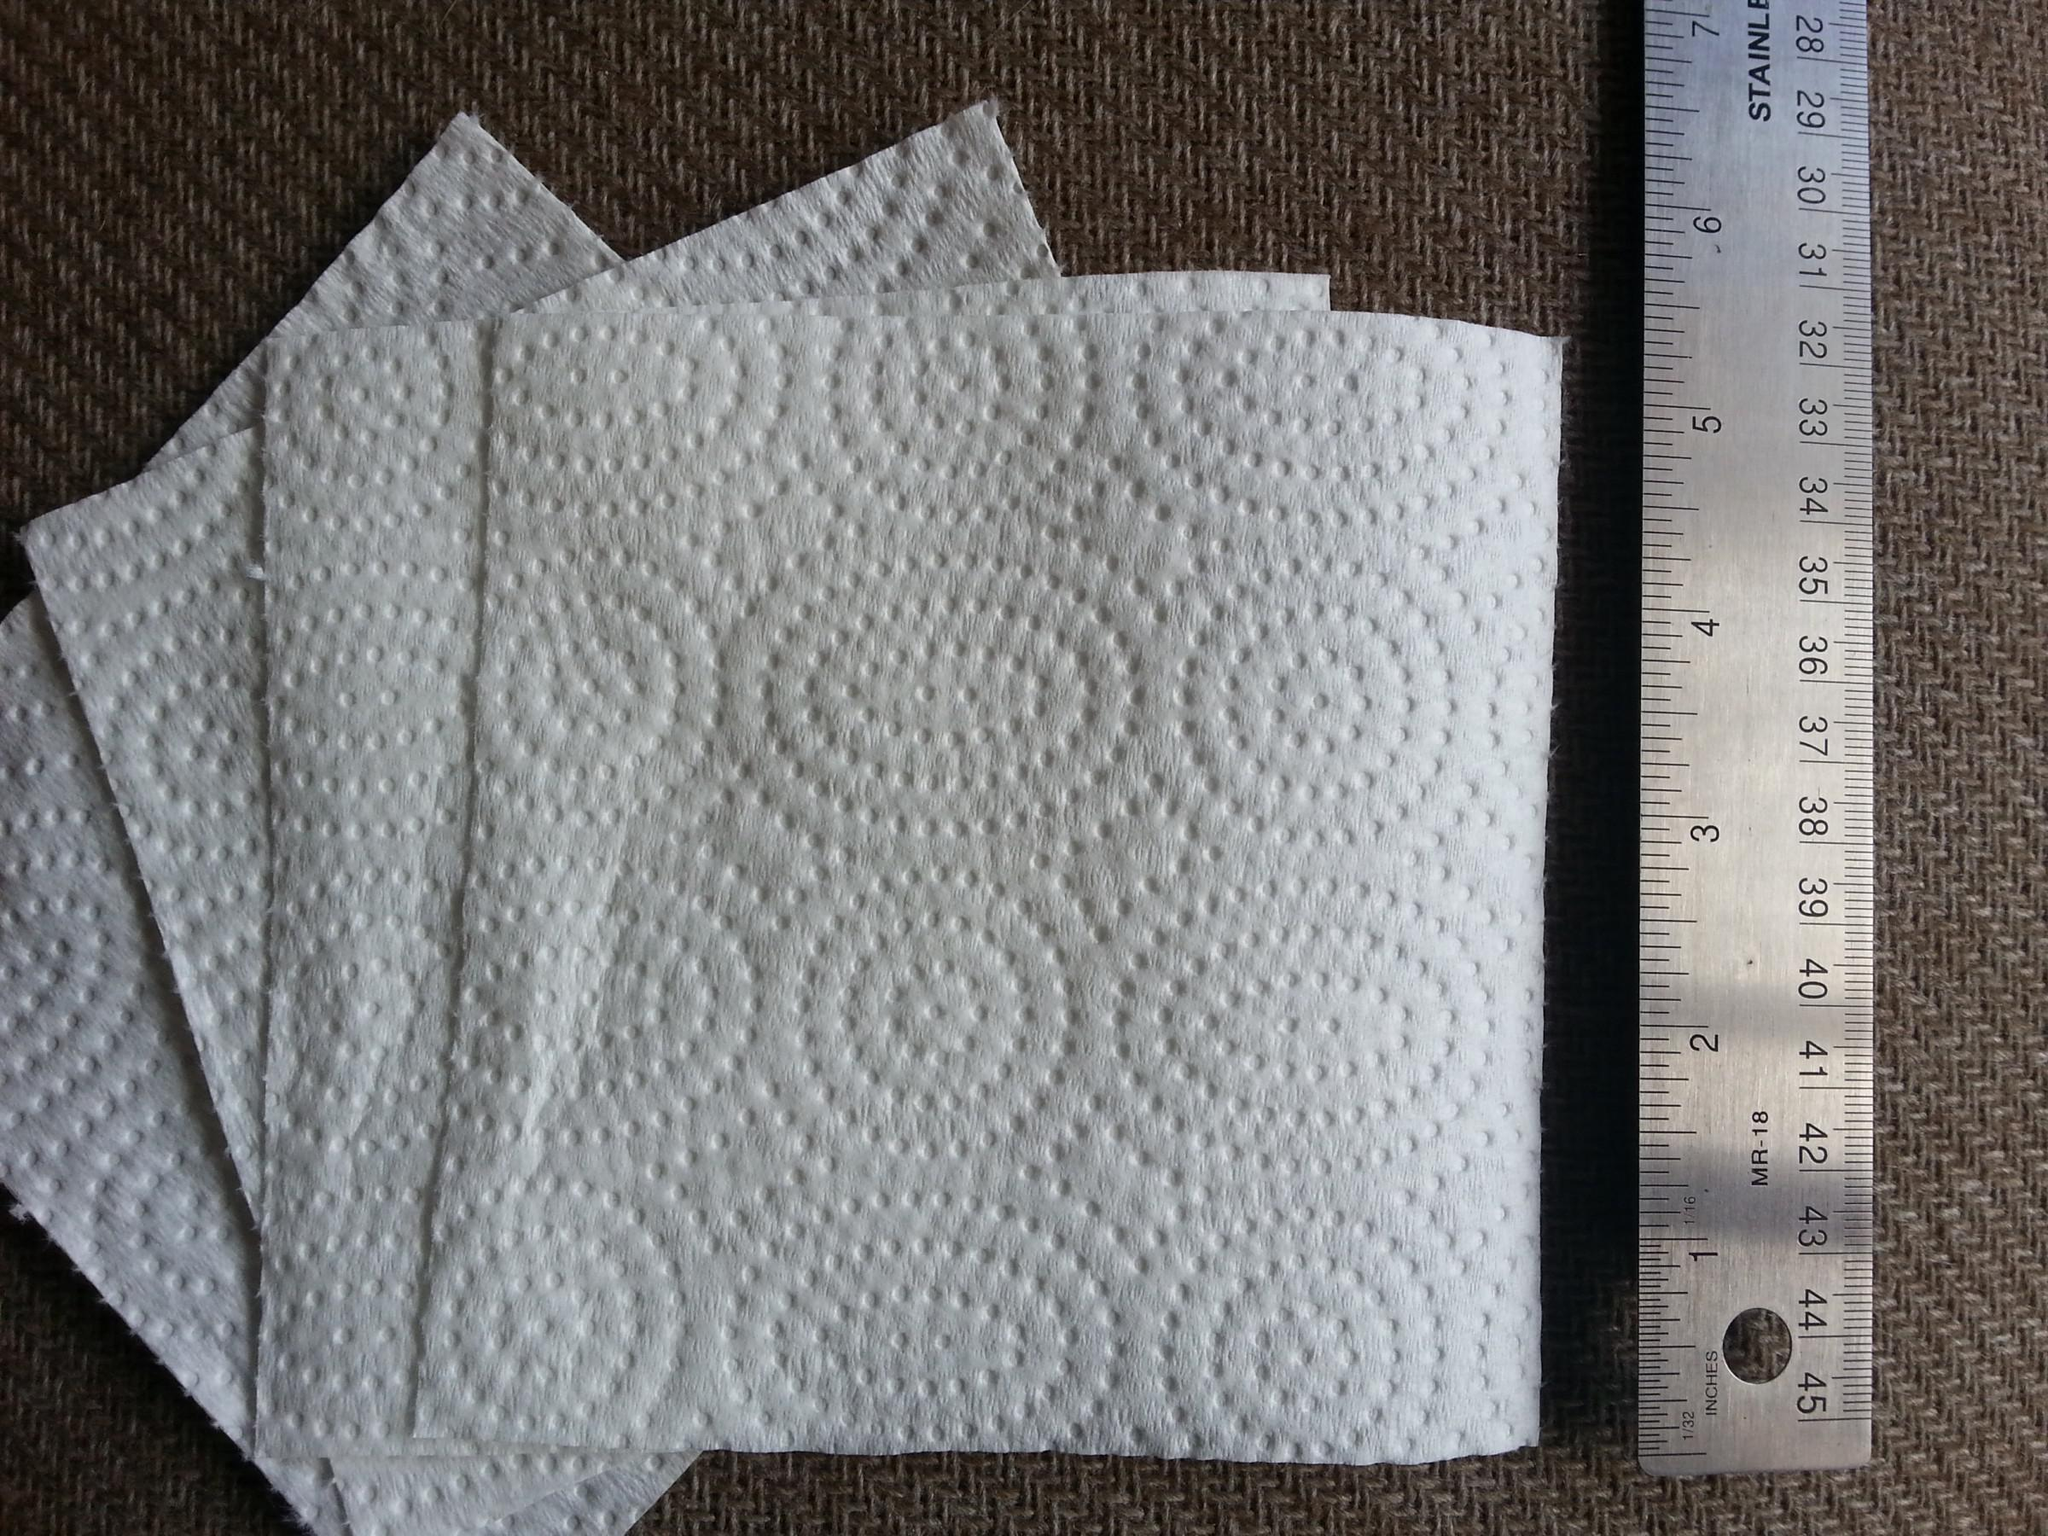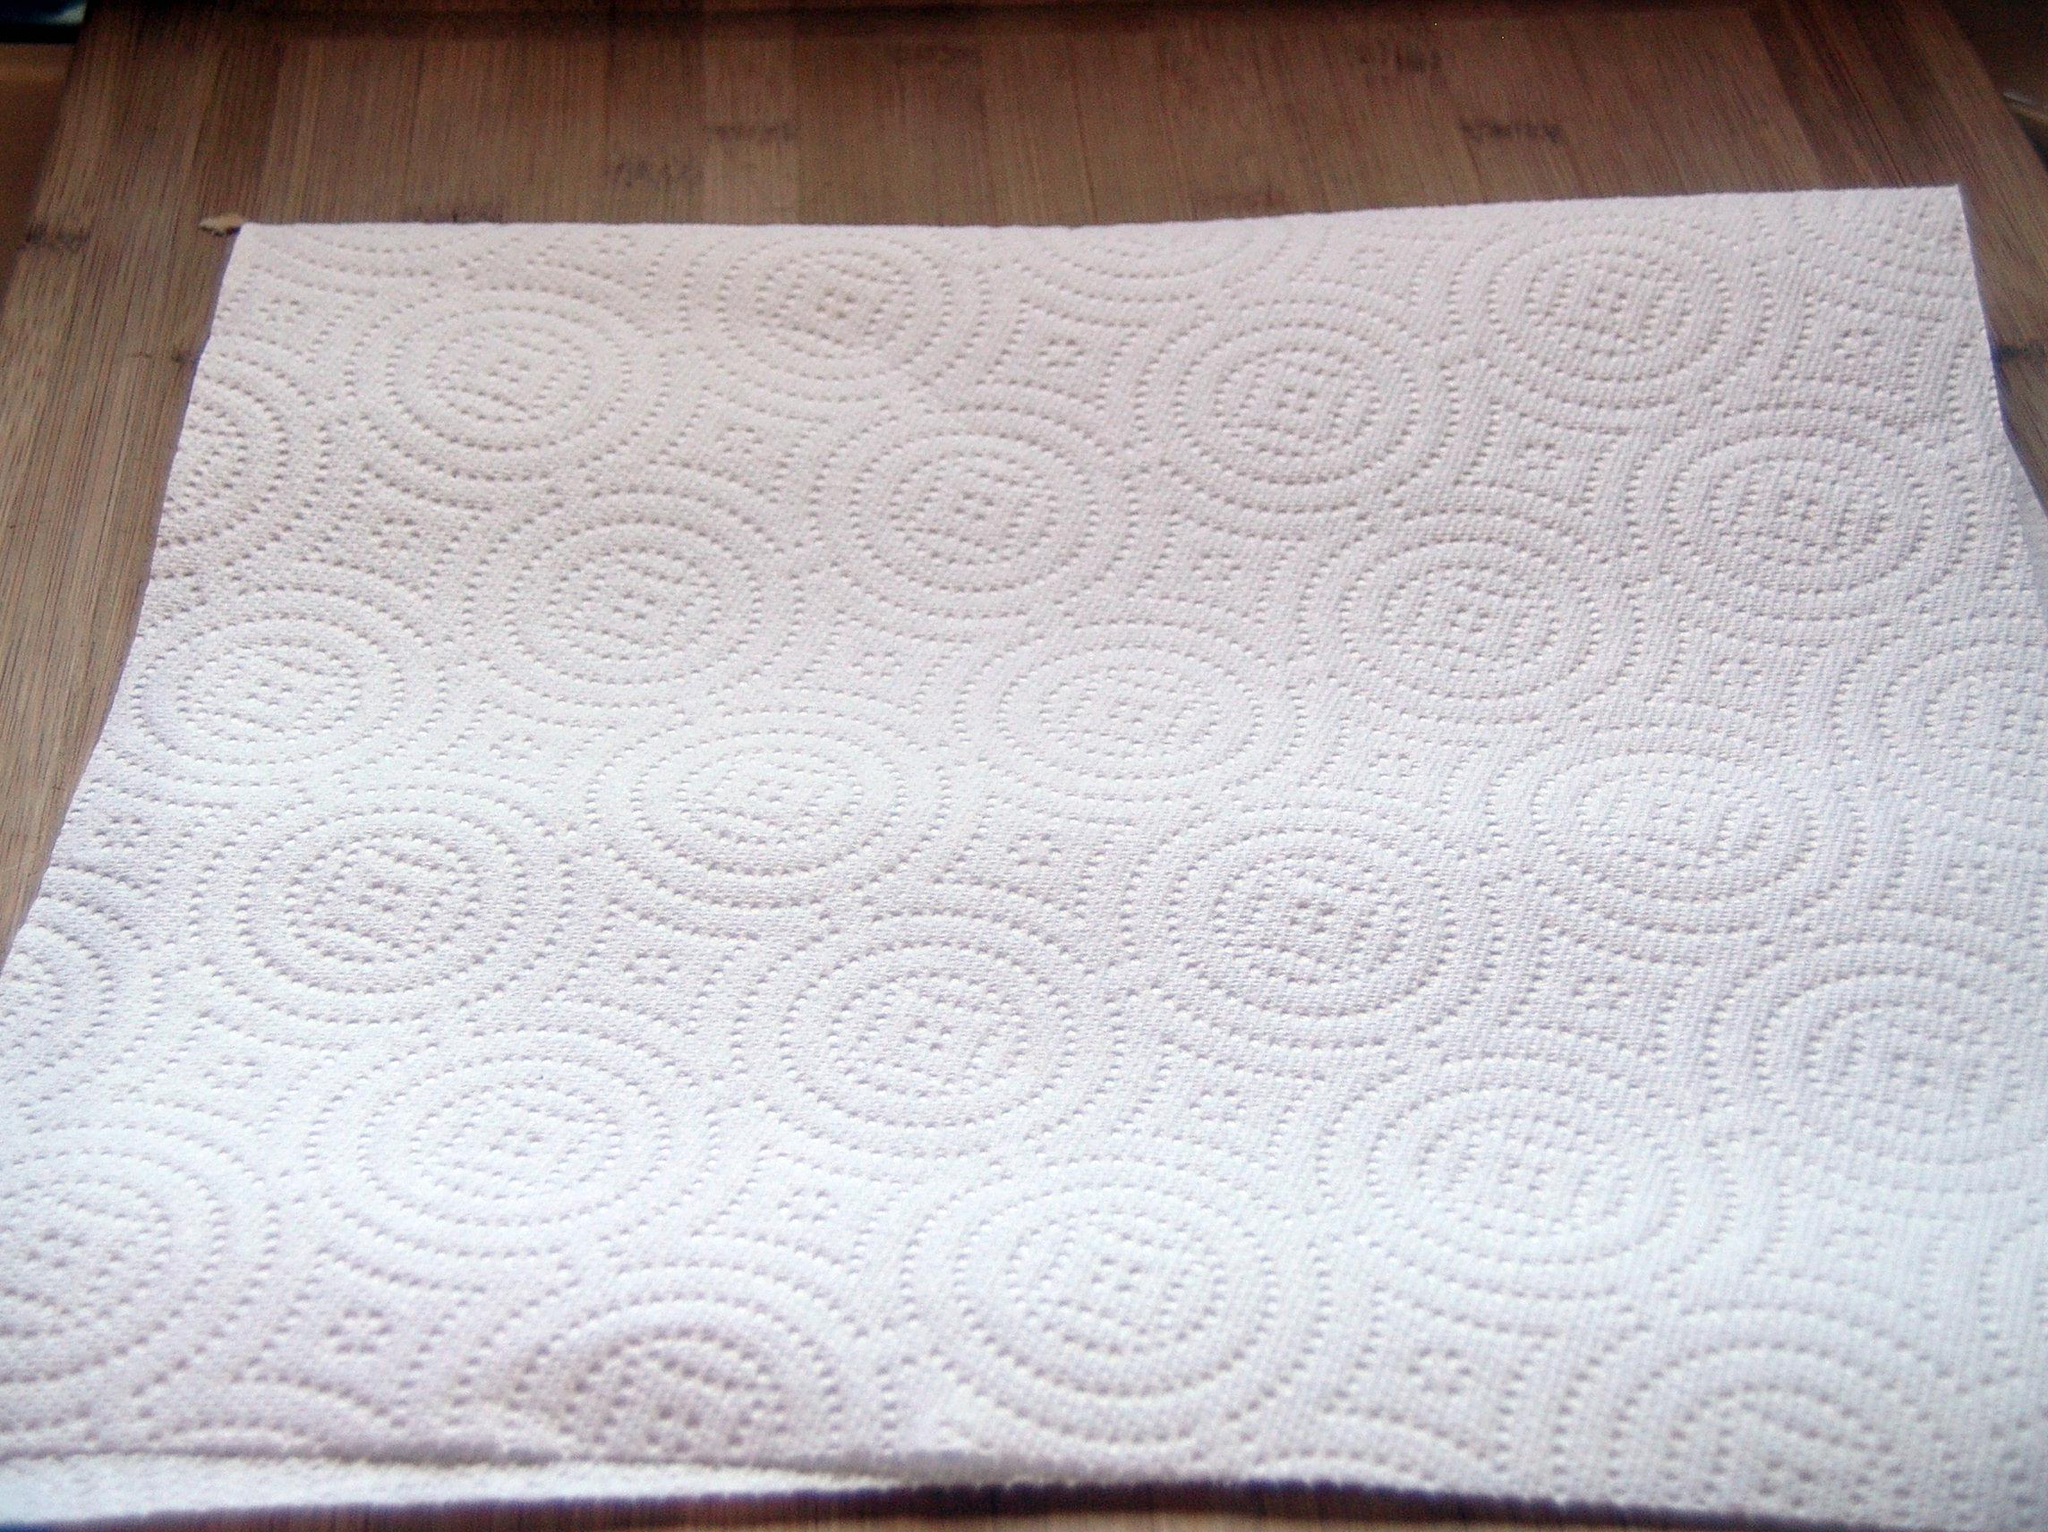The first image is the image on the left, the second image is the image on the right. Assess this claim about the two images: "An image shows overlapping square white paper towels, each with the same embossed pattern.". Correct or not? Answer yes or no. Yes. The first image is the image on the left, the second image is the image on the right. Given the left and right images, does the statement "There are exactly five visible paper towels." hold true? Answer yes or no. Yes. 